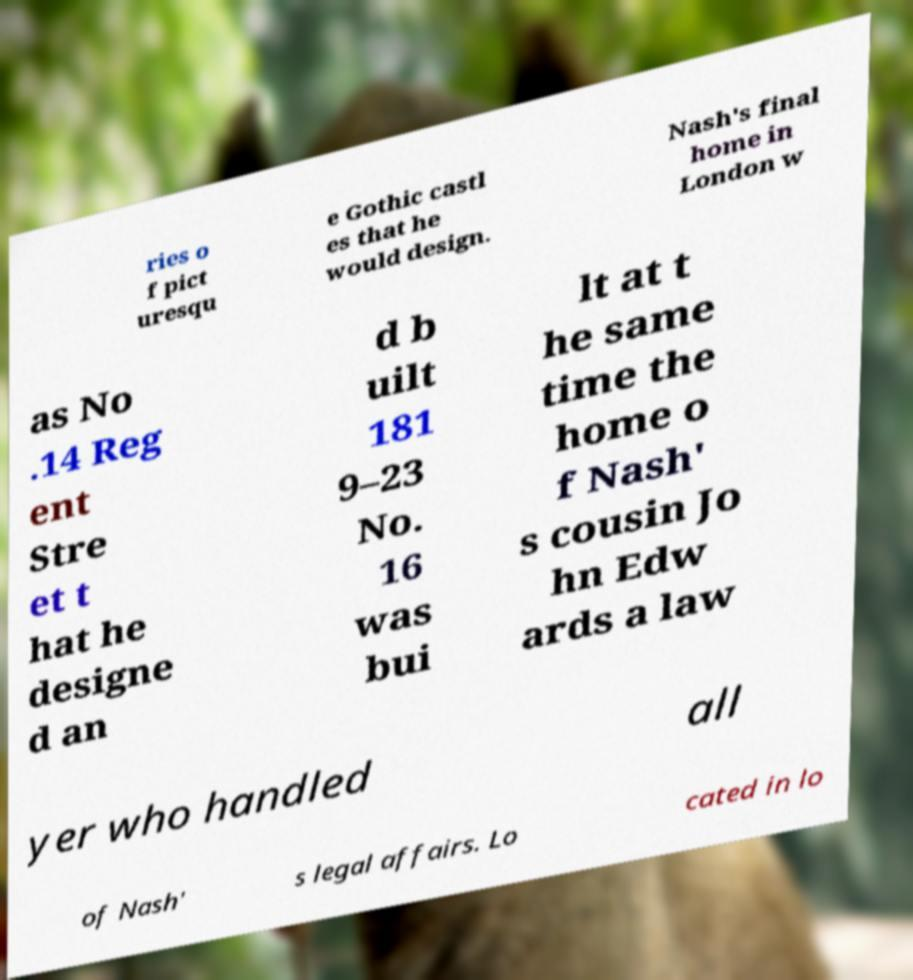There's text embedded in this image that I need extracted. Can you transcribe it verbatim? ries o f pict uresqu e Gothic castl es that he would design. Nash's final home in London w as No .14 Reg ent Stre et t hat he designe d an d b uilt 181 9–23 No. 16 was bui lt at t he same time the home o f Nash' s cousin Jo hn Edw ards a law yer who handled all of Nash' s legal affairs. Lo cated in lo 